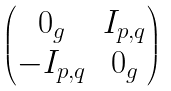Convert formula to latex. <formula><loc_0><loc_0><loc_500><loc_500>\begin{pmatrix} 0 _ { g } & I _ { p , q } \\ - I _ { p , q } & 0 _ { g } \end{pmatrix}</formula> 